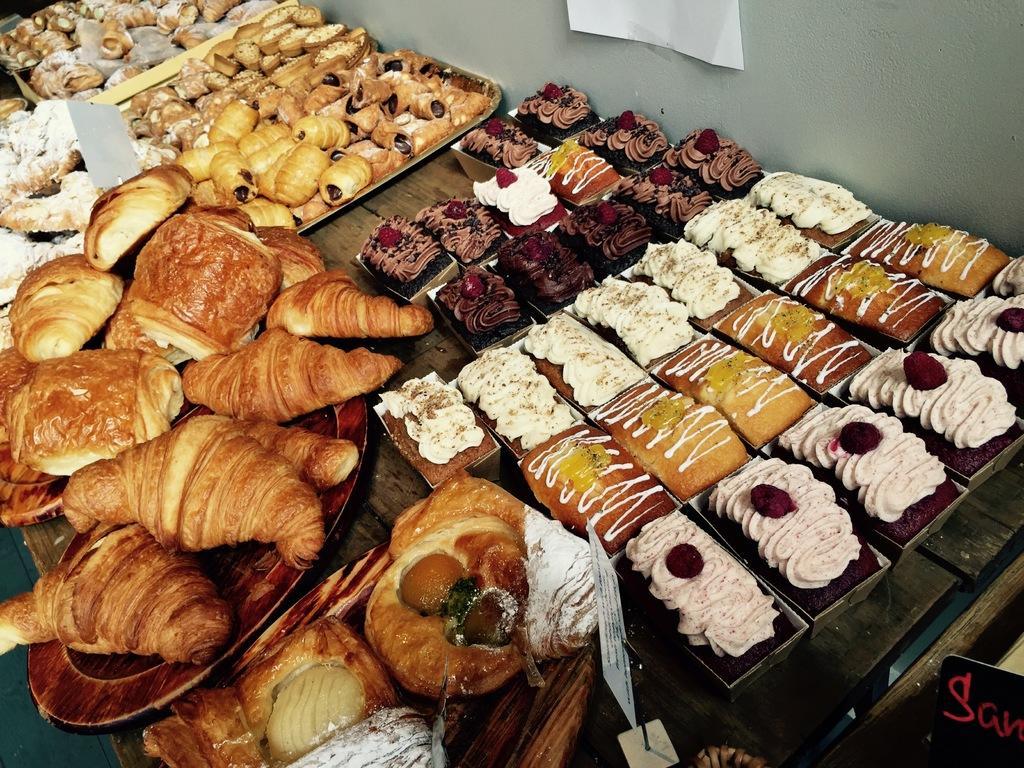Please provide a concise description of this image. In this image there are croissants, cakes and some food items on the plates and trays with the name boards on the table, and in the background there is a wall. 